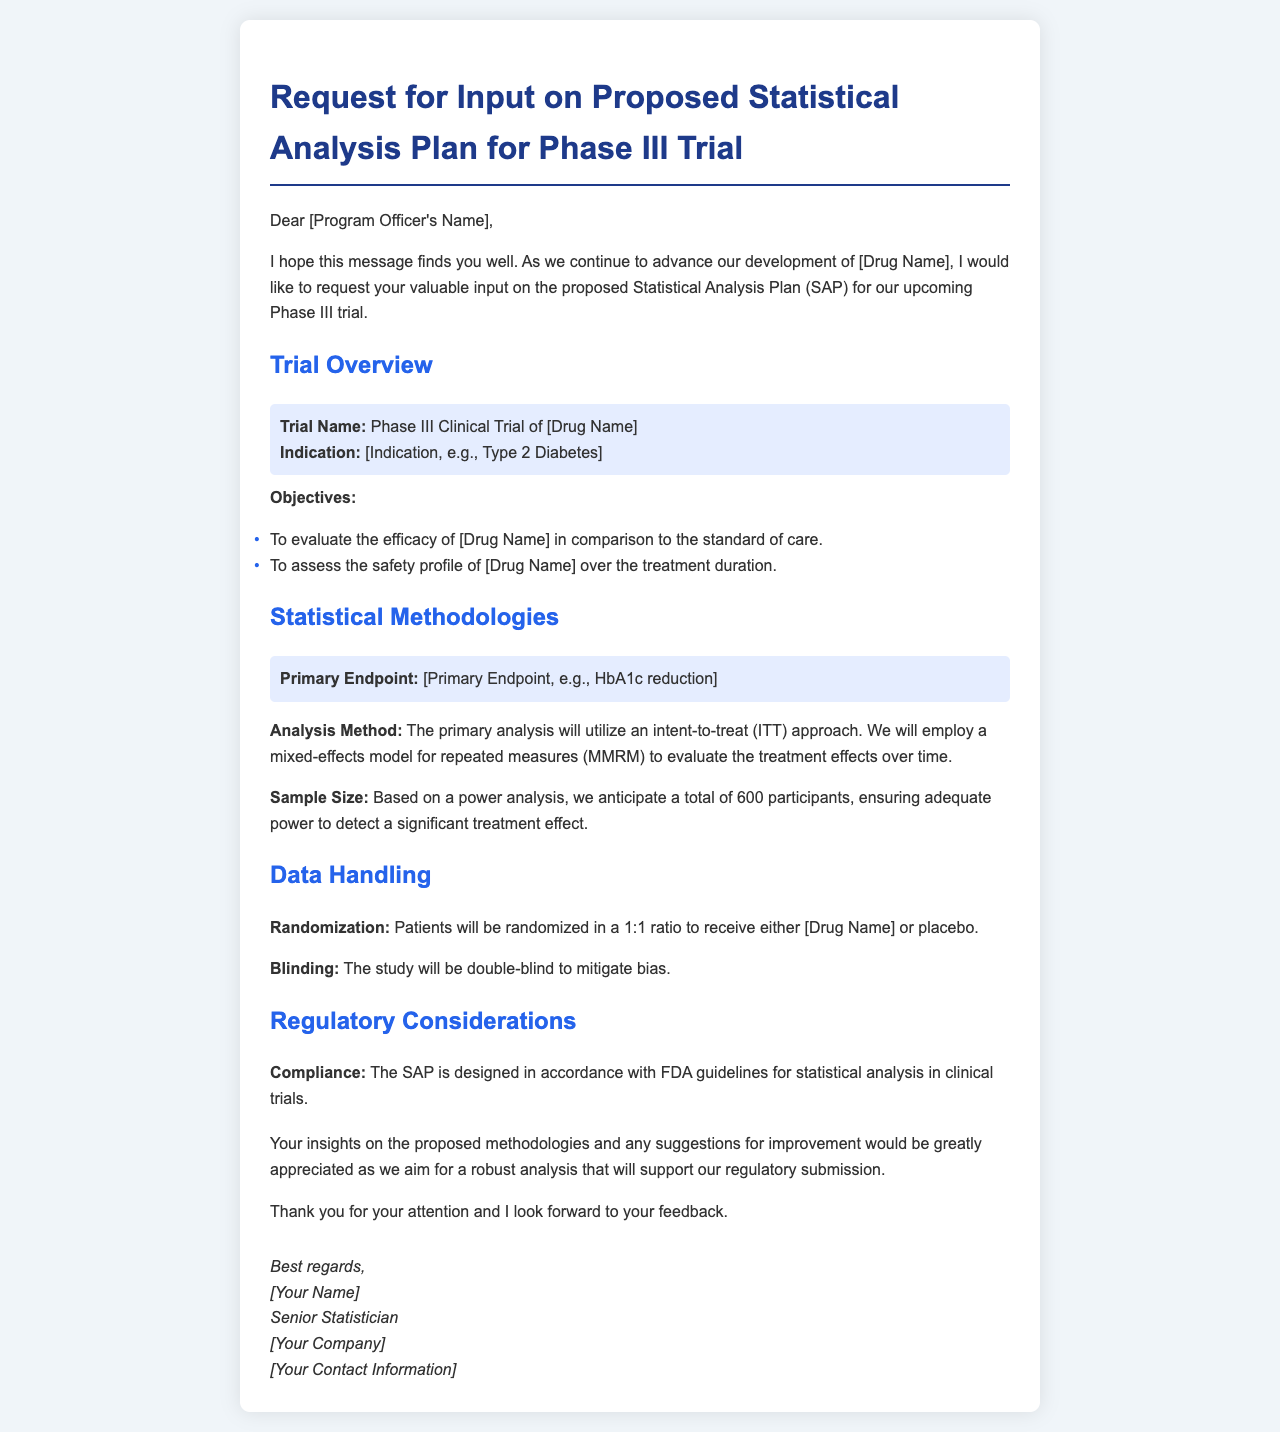What is the trial name? The trial name is provided in the overview section of the document.
Answer: Phase III Clinical Trial of [Drug Name] What is the primary endpoint? The primary endpoint is specified in the Statistical Methodologies section of the document.
Answer: [Primary Endpoint, e.g., HbA1c reduction] How many participants are anticipated for the study? The sample size is indicated in the Statistical Methodologies section, calculated for adequate power.
Answer: 600 What is the randomization ratio for the trial? The randomization ratio is outlined in the Data Handling section of the document.
Answer: 1:1 What type of study blinding is used? The blinding method is mentioned in the Data Handling section.
Answer: Double-blind What analysis method will be employed for the primary analysis? The analysis method is described in the Statistical Methodologies section.
Answer: Mixed-effects model for repeated measures (MMRM) What are the two main objectives of the trial? The objectives are listed in the Trial Overview section and entail efficacy and safety evaluation.
Answer: Efficacy and safety What guidelines does the SAP follow? The compliance aspect is noted in the Regulatory Considerations section regarding guidelines.
Answer: FDA guidelines 